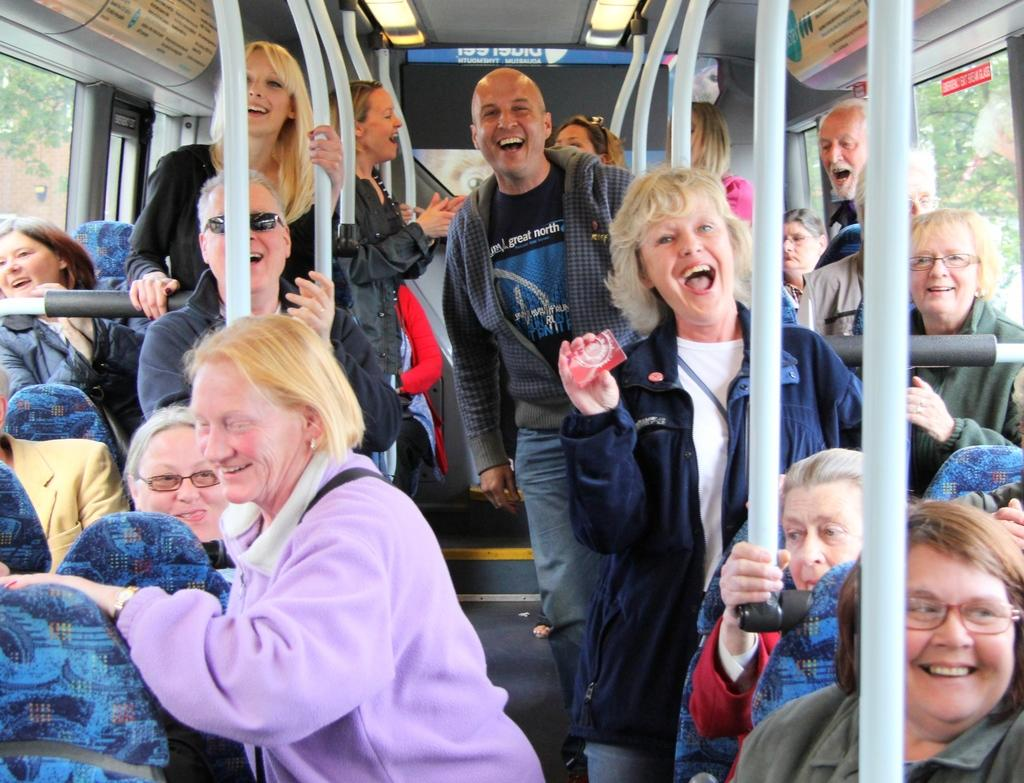Who is present in the image? There are people in the image. Where are the people located? The people are on a bus. What are the people doing on the bus? The people are either sitting or standing. What expressions do the people have on their faces? The people have smiles on their faces. What is the texture of the boundary in the image? There is no boundary present in the image, so it is not possible to determine its texture. 